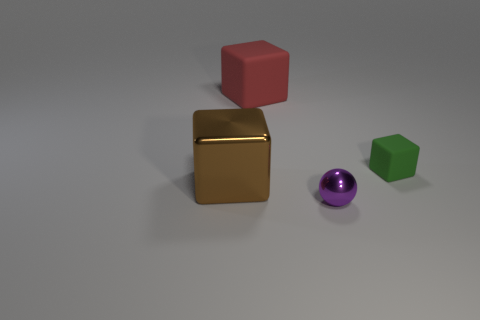There is a large red block; are there any big red blocks left of it?
Offer a terse response. No. There is a red matte cube; is its size the same as the block right of the big red block?
Your response must be concise. No. What is the size of the other matte object that is the same shape as the big red matte thing?
Provide a succinct answer. Small. There is a rubber cube to the left of the purple object; is it the same size as the rubber object that is in front of the big red block?
Provide a succinct answer. No. How many big things are either brown matte balls or brown objects?
Keep it short and to the point. 1. What number of objects are in front of the green thing and on the left side of the purple shiny ball?
Your response must be concise. 1. Is the material of the small purple object the same as the cube that is right of the small purple ball?
Provide a succinct answer. No. How many brown objects are either rubber cubes or metal things?
Give a very brief answer. 1. Is there another metal cube of the same size as the brown block?
Offer a very short reply. No. The large block that is behind the tiny thing that is right of the shiny thing on the right side of the large brown shiny cube is made of what material?
Offer a terse response. Rubber. 